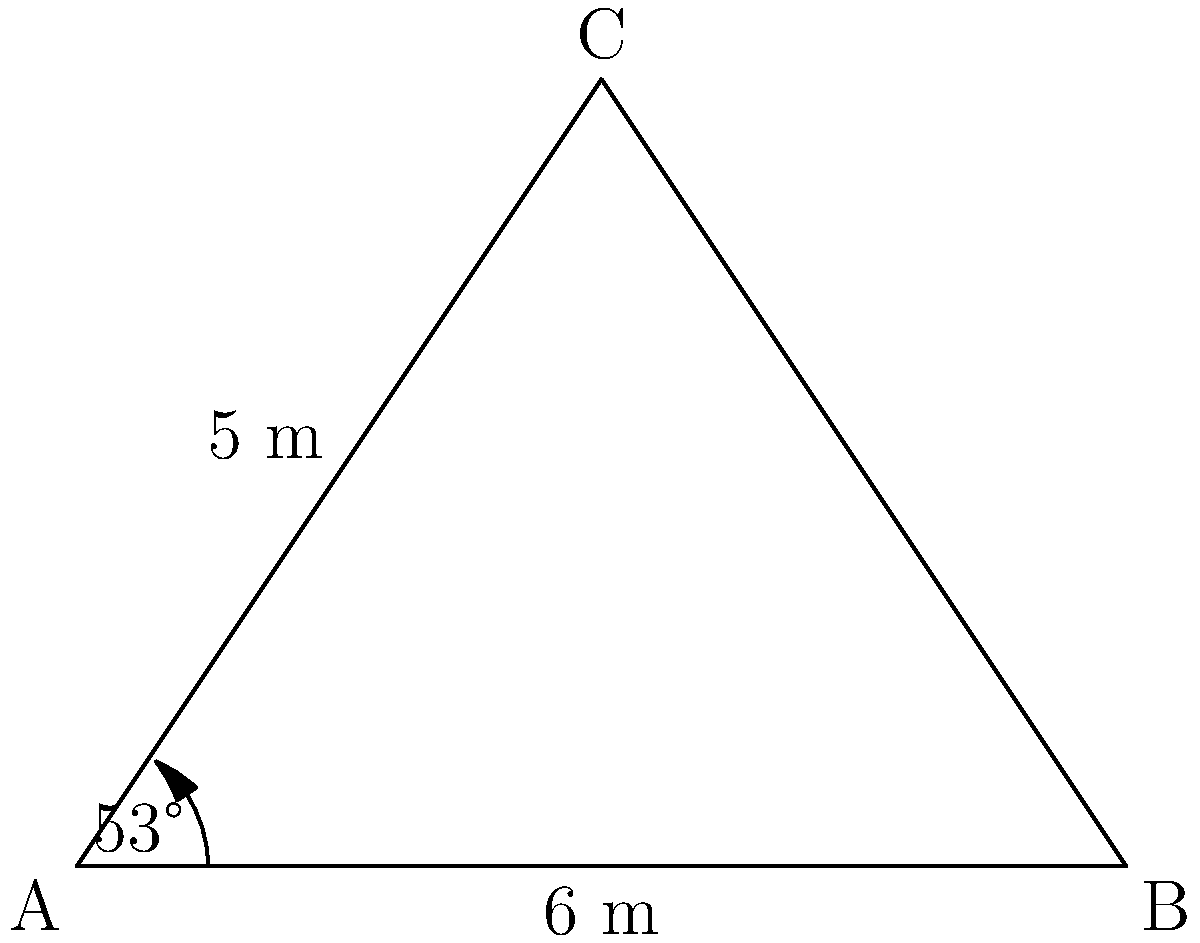In a triangular military formation, two sides measure 5 m and 6 m, with an included angle of 53°. Calculate the area of this formation to the nearest square meter. To solve this problem, we'll use the formula for the area of a triangle given two sides and the included angle:

$$A = \frac{1}{2} ab \sin C$$

Where:
$A$ = Area of the triangle
$a$ and $b$ = The two known sides
$C$ = The included angle

Step 1: Identify the given information
$a = 5$ m
$b = 6$ m
$C = 53°$

Step 2: Convert the angle to radians (not necessary if your calculator uses degrees)
$53° = 53 \times \frac{\pi}{180} \approx 0.9250$ radians

Step 3: Apply the formula
$$A = \frac{1}{2} \times 5 \times 6 \times \sin(53°)$$

Step 4: Calculate
$$A = 15 \times \sin(53°)$$
$$A = 15 \times 0.7986$$
$$A = 11.979$$ square meters

Step 5: Round to the nearest square meter
$A \approx 12$ square meters

Therefore, the area of the triangular military formation is approximately 12 square meters.
Answer: 12 m² 